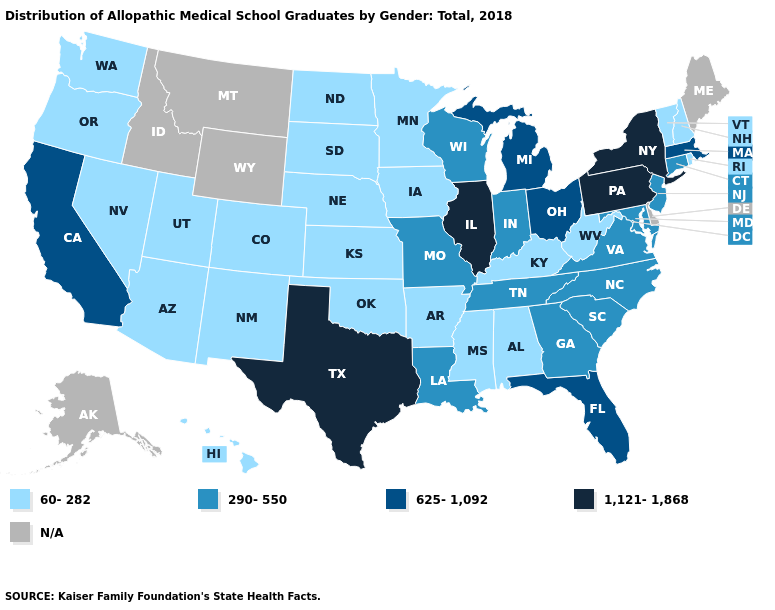Name the states that have a value in the range 60-282?
Keep it brief. Alabama, Arizona, Arkansas, Colorado, Hawaii, Iowa, Kansas, Kentucky, Minnesota, Mississippi, Nebraska, Nevada, New Hampshire, New Mexico, North Dakota, Oklahoma, Oregon, Rhode Island, South Dakota, Utah, Vermont, Washington, West Virginia. What is the highest value in the MidWest ?
Write a very short answer. 1,121-1,868. What is the value of Iowa?
Keep it brief. 60-282. Among the states that border Oregon , which have the lowest value?
Be succinct. Nevada, Washington. What is the value of Connecticut?
Be succinct. 290-550. Among the states that border Maryland , which have the highest value?
Keep it brief. Pennsylvania. Which states hav the highest value in the Northeast?
Write a very short answer. New York, Pennsylvania. Which states have the highest value in the USA?
Short answer required. Illinois, New York, Pennsylvania, Texas. Name the states that have a value in the range 60-282?
Keep it brief. Alabama, Arizona, Arkansas, Colorado, Hawaii, Iowa, Kansas, Kentucky, Minnesota, Mississippi, Nebraska, Nevada, New Hampshire, New Mexico, North Dakota, Oklahoma, Oregon, Rhode Island, South Dakota, Utah, Vermont, Washington, West Virginia. What is the value of Oklahoma?
Quick response, please. 60-282. Does Hawaii have the lowest value in the USA?
Answer briefly. Yes. Among the states that border Oklahoma , which have the highest value?
Concise answer only. Texas. What is the value of Wisconsin?
Keep it brief. 290-550. What is the value of Montana?
Answer briefly. N/A. 